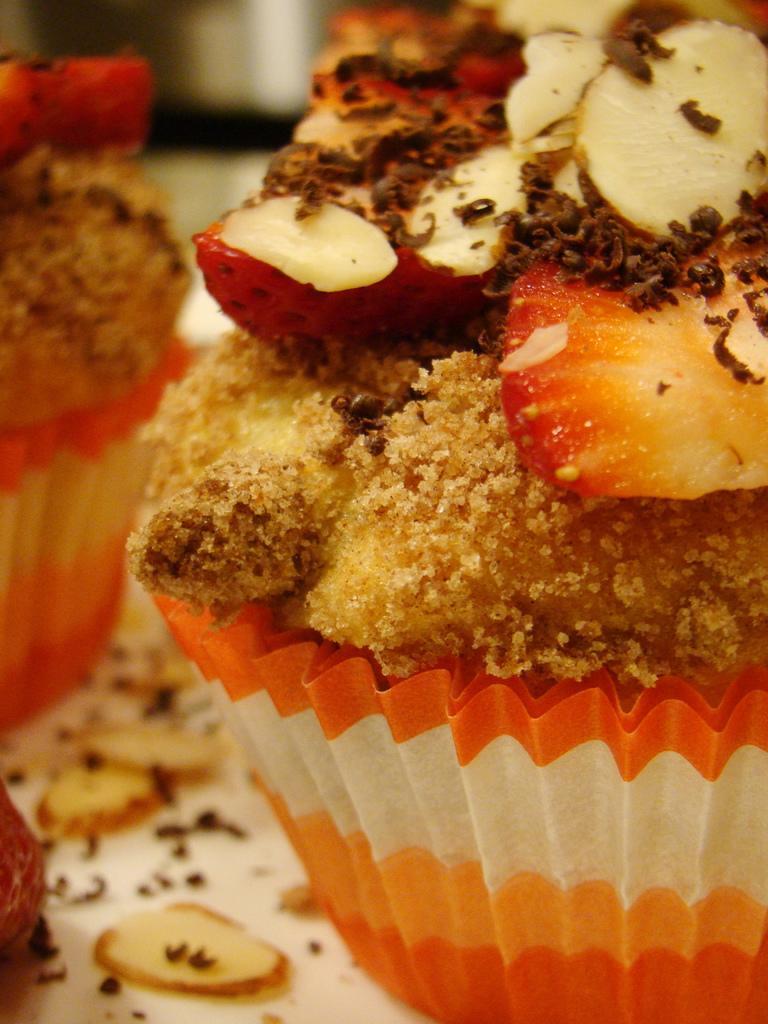Describe this image in one or two sentences. In this image we can see the cupcakes with some food items on the table. 